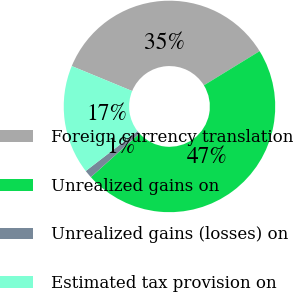Convert chart to OTSL. <chart><loc_0><loc_0><loc_500><loc_500><pie_chart><fcel>Foreign currency translation<fcel>Unrealized gains on<fcel>Unrealized gains (losses) on<fcel>Estimated tax provision on<nl><fcel>35.01%<fcel>47.1%<fcel>1.2%<fcel>16.69%<nl></chart> 